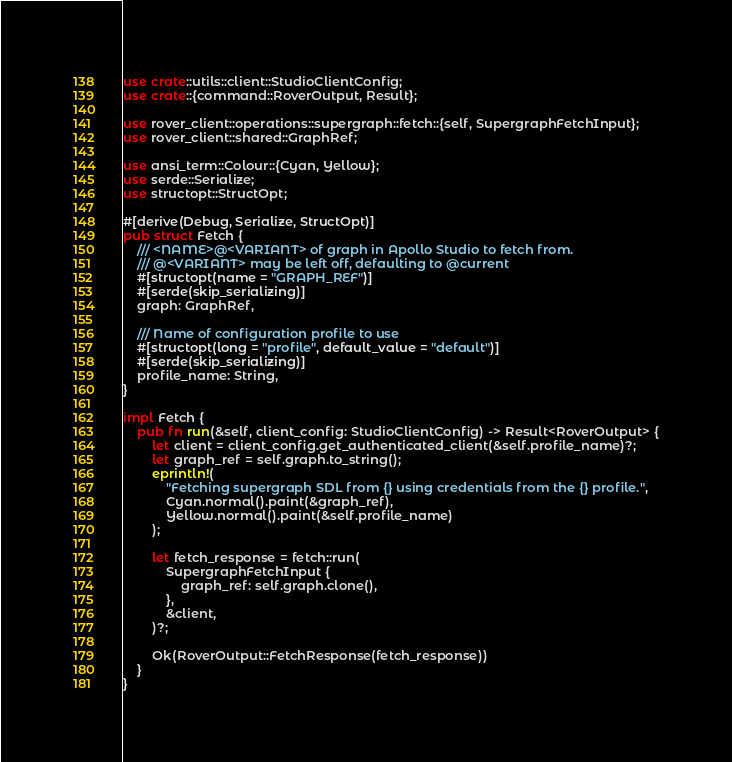Convert code to text. <code><loc_0><loc_0><loc_500><loc_500><_Rust_>use crate::utils::client::StudioClientConfig;
use crate::{command::RoverOutput, Result};

use rover_client::operations::supergraph::fetch::{self, SupergraphFetchInput};
use rover_client::shared::GraphRef;

use ansi_term::Colour::{Cyan, Yellow};
use serde::Serialize;
use structopt::StructOpt;

#[derive(Debug, Serialize, StructOpt)]
pub struct Fetch {
    /// <NAME>@<VARIANT> of graph in Apollo Studio to fetch from.
    /// @<VARIANT> may be left off, defaulting to @current
    #[structopt(name = "GRAPH_REF")]
    #[serde(skip_serializing)]
    graph: GraphRef,

    /// Name of configuration profile to use
    #[structopt(long = "profile", default_value = "default")]
    #[serde(skip_serializing)]
    profile_name: String,
}

impl Fetch {
    pub fn run(&self, client_config: StudioClientConfig) -> Result<RoverOutput> {
        let client = client_config.get_authenticated_client(&self.profile_name)?;
        let graph_ref = self.graph.to_string();
        eprintln!(
            "Fetching supergraph SDL from {} using credentials from the {} profile.",
            Cyan.normal().paint(&graph_ref),
            Yellow.normal().paint(&self.profile_name)
        );

        let fetch_response = fetch::run(
            SupergraphFetchInput {
                graph_ref: self.graph.clone(),
            },
            &client,
        )?;

        Ok(RoverOutput::FetchResponse(fetch_response))
    }
}
</code> 